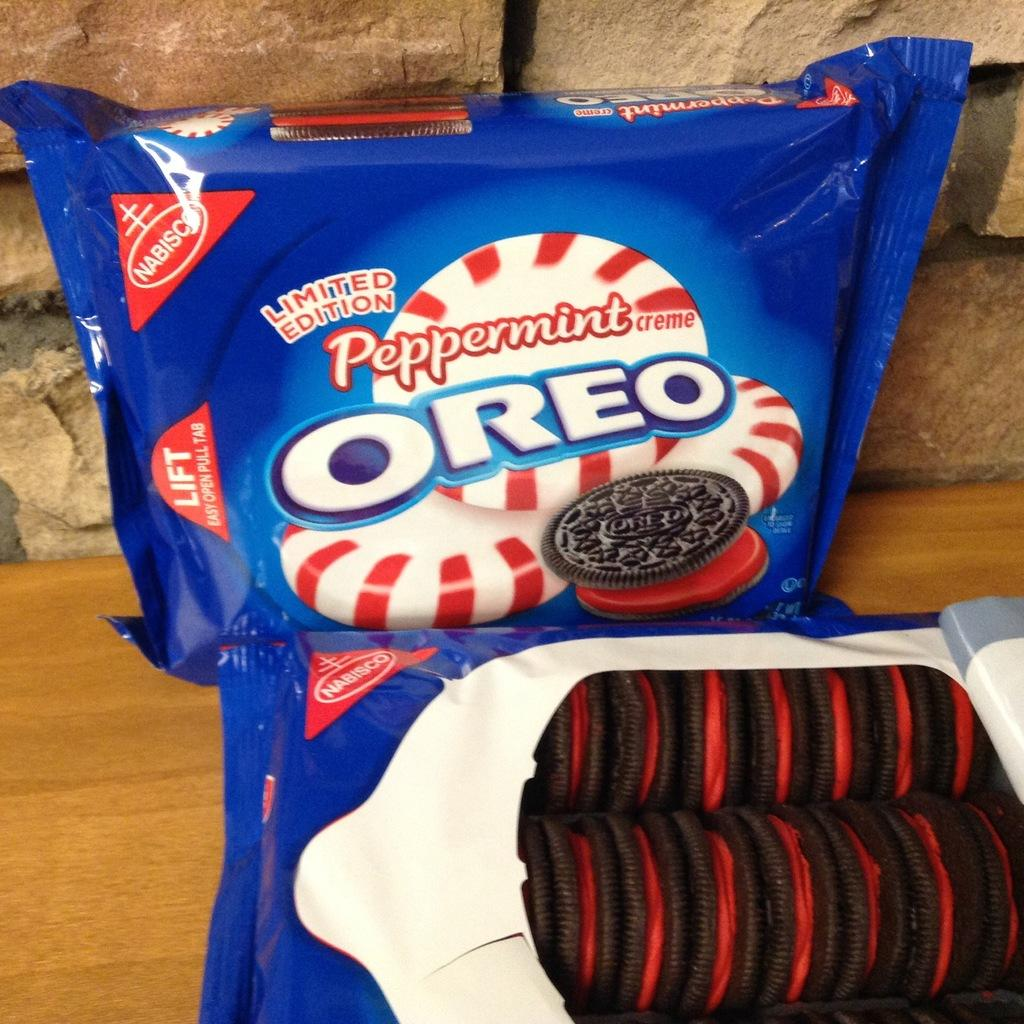What type of objects can be seen in the image? There are food items in the image. How are the food items presented? The food items are wrapped in a cover. What type of surface is visible in the image? There is a wooden surface visible in the image. What type of structure can be seen in the background? There is a stone wall in the image. What type of mint plant can be seen growing on the wooden surface in the image? There is no mint plant visible in the image; it only features food items wrapped in a cover, a wooden surface, and a stone wall in the background. 